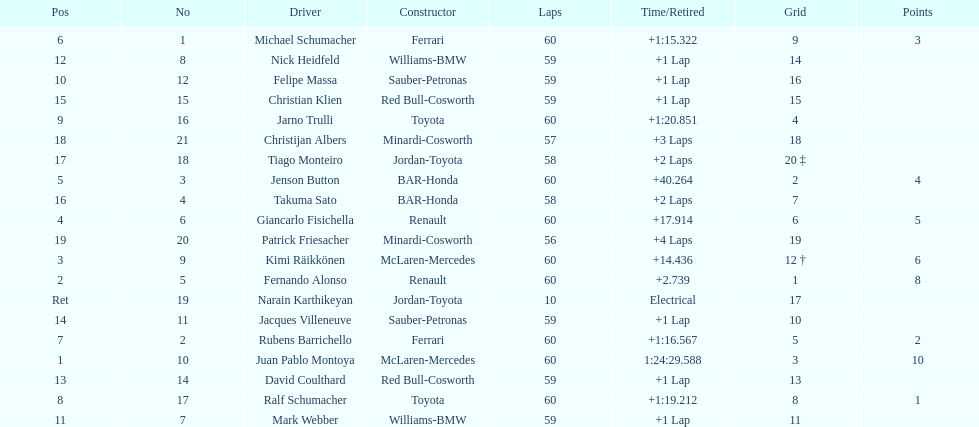Which driver has his grid at 2? Jenson Button. 